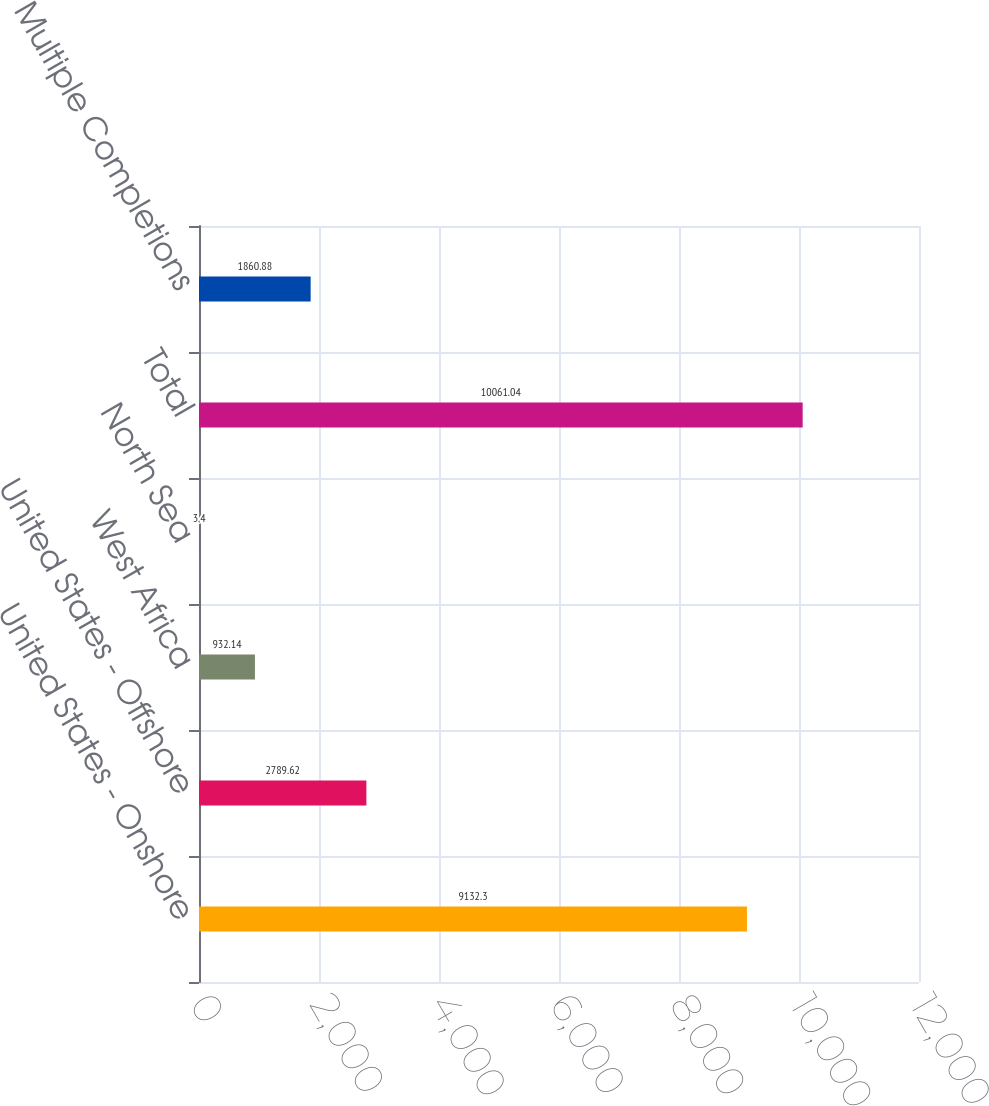<chart> <loc_0><loc_0><loc_500><loc_500><bar_chart><fcel>United States - Onshore<fcel>United States - Offshore<fcel>West Africa<fcel>North Sea<fcel>Total<fcel>Multiple Completions<nl><fcel>9132.3<fcel>2789.62<fcel>932.14<fcel>3.4<fcel>10061<fcel>1860.88<nl></chart> 